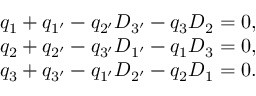Convert formula to latex. <formula><loc_0><loc_0><loc_500><loc_500>\begin{array} { r l } & { q _ { 1 } + q _ { 1 ^ { \prime } } - q _ { 2 ^ { \prime } } { D } _ { 3 ^ { \prime } } - q _ { 3 } { D } _ { 2 } = 0 , } \\ & { q _ { 2 } + q _ { 2 ^ { \prime } } - q _ { 3 ^ { \prime } } { D } _ { 1 ^ { \prime } } - q _ { 1 } { D } _ { 3 } = 0 , } \\ & { q _ { 3 } + q _ { 3 ^ { \prime } } - q _ { 1 ^ { \prime } } { D } _ { 2 ^ { \prime } } - q _ { 2 } { D } _ { 1 } = 0 . } \end{array}</formula> 